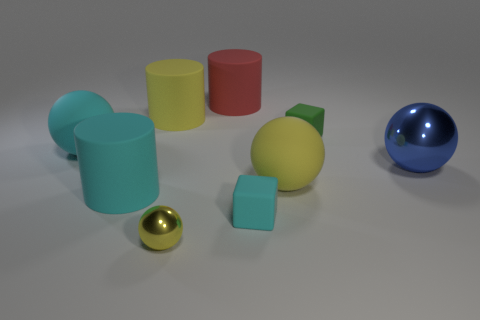What is the size of the sphere left of the shiny sphere left of the large yellow matte object that is in front of the large cyan ball?
Give a very brief answer. Large. What number of objects are either cylinders that are in front of the green object or small green rubber objects?
Offer a terse response. 2. How many metal things are behind the metallic object that is in front of the cyan rubber cylinder?
Your answer should be very brief. 1. Are there more blue spheres left of the big red rubber cylinder than small yellow balls?
Offer a terse response. No. There is a cyan matte thing that is both left of the large red rubber object and in front of the large yellow matte ball; what size is it?
Your answer should be very brief. Large. What is the shape of the large matte object that is both right of the small yellow metal ball and behind the big yellow matte sphere?
Offer a very short reply. Cylinder. There is a small yellow metal object to the left of the cube that is to the right of the cyan matte block; is there a yellow ball that is right of it?
Your answer should be compact. Yes. What number of objects are either shiny spheres to the left of the blue metal thing or matte things left of the big red matte object?
Provide a succinct answer. 4. Is the cylinder that is to the right of the small yellow thing made of the same material as the small cyan cube?
Provide a succinct answer. Yes. There is a yellow object that is both in front of the blue metallic ball and behind the small yellow object; what is its material?
Your answer should be very brief. Rubber. 